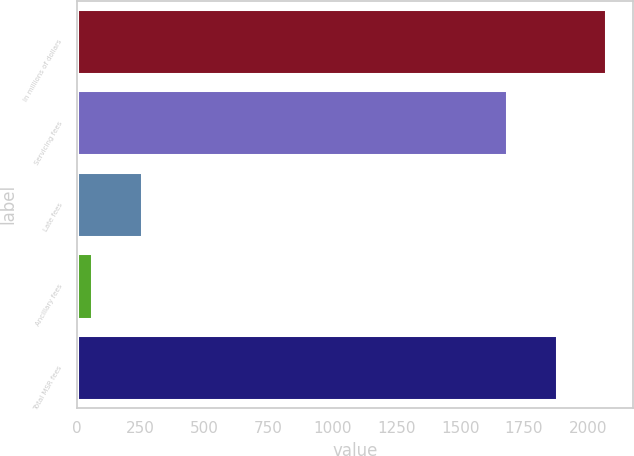<chart> <loc_0><loc_0><loc_500><loc_500><bar_chart><fcel>In millions of dollars<fcel>Servicing fees<fcel>Late fees<fcel>Ancillary fees<fcel>Total MSR fees<nl><fcel>2072.2<fcel>1683<fcel>255.6<fcel>61<fcel>1877.6<nl></chart> 